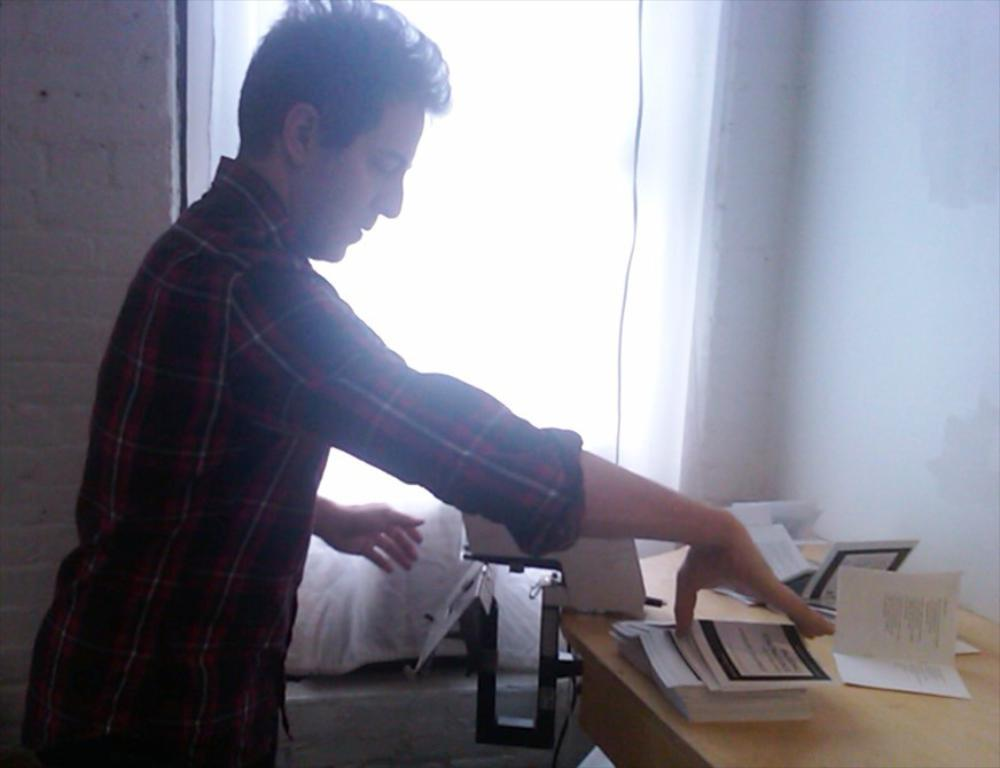What is the man in the image doing? The man is standing in the image and holding books in his hand. What is located in front of the man? There is a table in front of the man. What can be found on the table? There are books on the table. What is visible in the background of the image? There is a wall and a window in the image. What type of tray is the man using to hold the books in the image? There is no tray present in the image; the man is holding the books in his hand. 